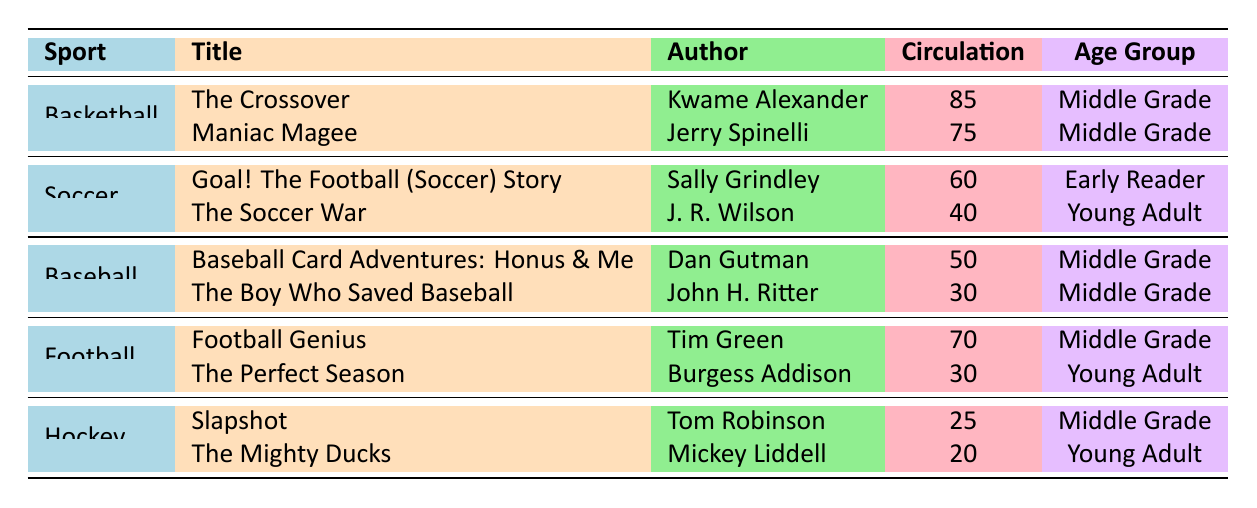What is the title of the basketball book with the highest circulation? According to the table, "The Crossover" by Kwame Alexander has the highest circulation count of 85 among basketball books.
Answer: The Crossover Which author wrote the baseball book with the lowest circulation? The table indicates that "The Boy Who Saved Baseball" by John H. Ritter has a lower circulation (30) compared to "Baseball Card Adventures: Honus & Me" (50), making it the book with the lowest circulation in baseball.
Answer: John H. Ritter How many soccer books have a circulation count of over 50? In the soccer category, "Goal! The Football (Soccer) Story" has a circulation of 60 and "The Soccer War" has 40. Only one book has over 50 circulations, which is "Goal! The Football (Soccer) Story."
Answer: 1 What is the total circulation of all hockey books listed? The hockey books listed are "Slapshot" (25) and "The Mighty Ducks" (20). Adding these together gives 25 + 20 = 45 for the total circulation of hockey books.
Answer: 45 Is there a baseball book that has a higher circulation than the highest football book? The highest football book is "Football Genius" with a circulation of 70, while the highest baseball book is "Baseball Card Adventures: Honus & Me" with a circulation of 50. Therefore, there is no baseball book with a higher circulation than the highest football book.
Answer: No Which sport has the highest combined circulation of its books? Calculating the total circulations: Basketball (85 + 75 = 160), Soccer (60 + 40 = 100), Baseball (50 + 30 = 80), Football (70 + 30 = 100), Hockey (25 + 20 = 45). The highest total is for basketball at 160.
Answer: Basketball What age group has the highest number of titles in the table? Analyzing the age groups in the table: Middle Grade has 5 titles from various sports, Early Reader has 1 title (soccer), and Young Adult has 3 titles (2 football, 1 soccer). Middle Grade has the highest number of titles.
Answer: Middle Grade 